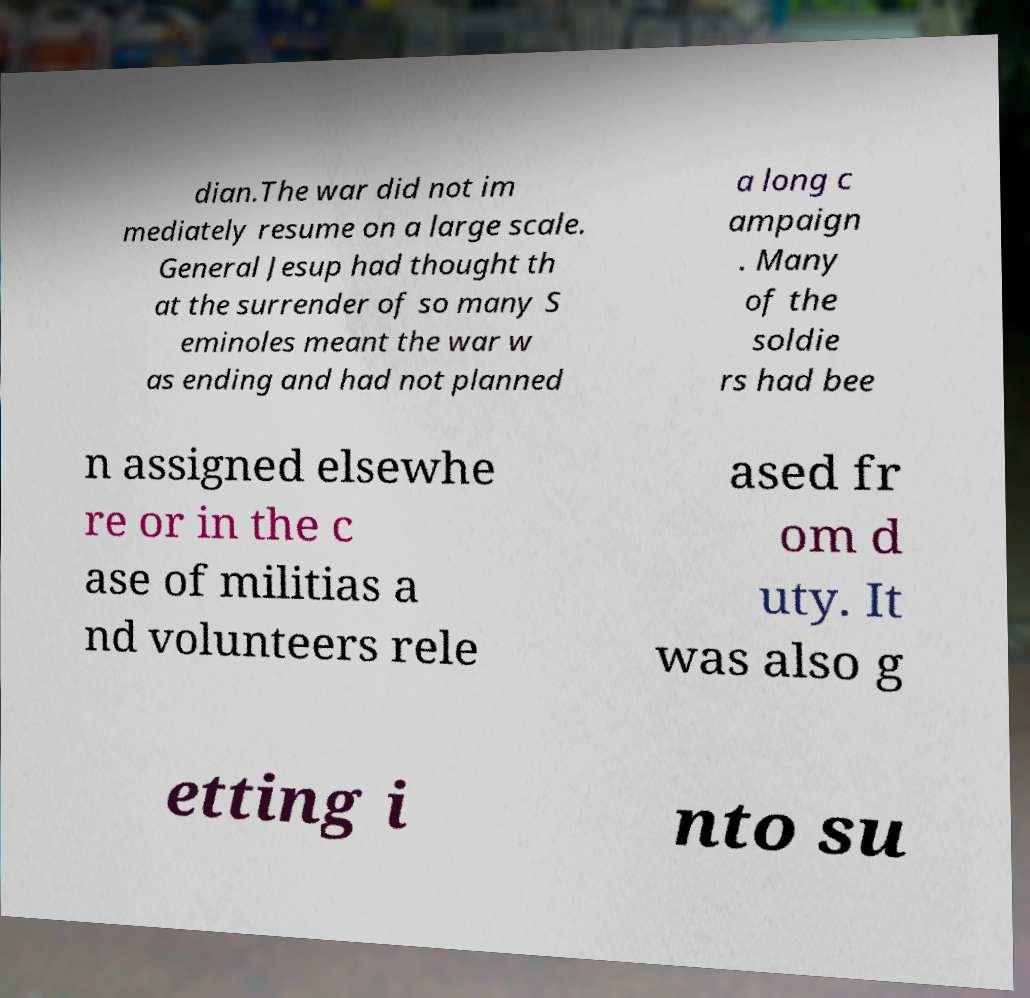What messages or text are displayed in this image? I need them in a readable, typed format. dian.The war did not im mediately resume on a large scale. General Jesup had thought th at the surrender of so many S eminoles meant the war w as ending and had not planned a long c ampaign . Many of the soldie rs had bee n assigned elsewhe re or in the c ase of militias a nd volunteers rele ased fr om d uty. It was also g etting i nto su 